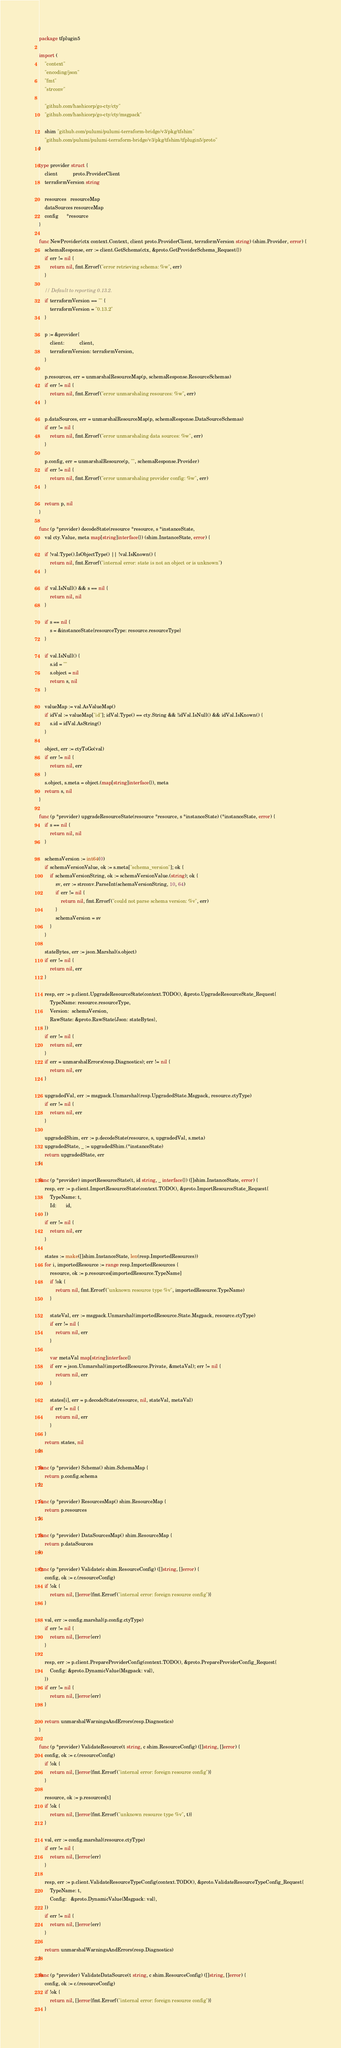<code> <loc_0><loc_0><loc_500><loc_500><_Go_>package tfplugin5

import (
	"context"
	"encoding/json"
	"fmt"
	"strconv"

	"github.com/hashicorp/go-cty/cty"
	"github.com/hashicorp/go-cty/cty/msgpack"

	shim "github.com/pulumi/pulumi-terraform-bridge/v3/pkg/tfshim"
	"github.com/pulumi/pulumi-terraform-bridge/v3/pkg/tfshim/tfplugin5/proto"
)

type provider struct {
	client           proto.ProviderClient
	terraformVersion string

	resources   resourceMap
	dataSources resourceMap
	config      *resource
}

func NewProvider(ctx context.Context, client proto.ProviderClient, terraformVersion string) (shim.Provider, error) {
	schemaResponse, err := client.GetSchema(ctx, &proto.GetProviderSchema_Request{})
	if err != nil {
		return nil, fmt.Errorf("error retrieving schema: %w", err)
	}

	// Default to reporting 0.13.2.
	if terraformVersion == "" {
		terraformVersion = "0.13.2"
	}

	p := &provider{
		client:           client,
		terraformVersion: terraformVersion,
	}

	p.resources, err = unmarshalResourceMap(p, schemaResponse.ResourceSchemas)
	if err != nil {
		return nil, fmt.Errorf("error unmarshaling resources: %w", err)
	}

	p.dataSources, err = unmarshalResourceMap(p, schemaResponse.DataSourceSchemas)
	if err != nil {
		return nil, fmt.Errorf("error unmarshaling data sources: %w", err)
	}

	p.config, err = unmarshalResource(p, "", schemaResponse.Provider)
	if err != nil {
		return nil, fmt.Errorf("error unmarshaling provider config: %w", err)
	}

	return p, nil
}

func (p *provider) decodeState(resource *resource, s *instanceState,
	val cty.Value, meta map[string]interface{}) (shim.InstanceState, error) {

	if !val.Type().IsObjectType() || !val.IsKnown() {
		return nil, fmt.Errorf("internal error: state is not an object or is unknown")
	}

	if val.IsNull() && s == nil {
		return nil, nil
	}

	if s == nil {
		s = &instanceState{resourceType: resource.resourceType}
	}

	if val.IsNull() {
		s.id = ""
		s.object = nil
		return s, nil
	}

	valueMap := val.AsValueMap()
	if idVal := valueMap["id"]; idVal.Type() == cty.String && !idVal.IsNull() && idVal.IsKnown() {
		s.id = idVal.AsString()
	}

	object, err := ctyToGo(val)
	if err != nil {
		return nil, err
	}
	s.object, s.meta = object.(map[string]interface{}), meta
	return s, nil
}

func (p *provider) upgradeResourceState(resource *resource, s *instanceState) (*instanceState, error) {
	if s == nil {
		return nil, nil
	}

	schemaVersion := int64(0)
	if schemaVersionValue, ok := s.meta["schema_version"]; ok {
		if schemaVersionString, ok := schemaVersionValue.(string); ok {
			sv, err := strconv.ParseInt(schemaVersionString, 10, 64)
			if err != nil {
				return nil, fmt.Errorf("could not parse schema version: %v", err)
			}
			schemaVersion = sv
		}
	}

	stateBytes, err := json.Marshal(s.object)
	if err != nil {
		return nil, err
	}

	resp, err := p.client.UpgradeResourceState(context.TODO(), &proto.UpgradeResourceState_Request{
		TypeName: resource.resourceType,
		Version:  schemaVersion,
		RawState: &proto.RawState{Json: stateBytes},
	})
	if err != nil {
		return nil, err
	}
	if err = unmarshalErrors(resp.Diagnostics); err != nil {
		return nil, err
	}

	upgradedVal, err := msgpack.Unmarshal(resp.UpgradedState.Msgpack, resource.ctyType)
	if err != nil {
		return nil, err
	}

	upgradedShim, err := p.decodeState(resource, s, upgradedVal, s.meta)
	upgradedState, _ := upgradedShim.(*instanceState)
	return upgradedState, err
}

func (p *provider) importResourceState(t, id string, _ interface{}) ([]shim.InstanceState, error) {
	resp, err := p.client.ImportResourceState(context.TODO(), &proto.ImportResourceState_Request{
		TypeName: t,
		Id:       id,
	})
	if err != nil {
		return nil, err
	}

	states := make([]shim.InstanceState, len(resp.ImportedResources))
	for i, importedResource := range resp.ImportedResources {
		resource, ok := p.resources[importedResource.TypeName]
		if !ok {
			return nil, fmt.Errorf("unknown resource type %v", importedResource.TypeName)
		}

		stateVal, err := msgpack.Unmarshal(importedResource.State.Msgpack, resource.ctyType)
		if err != nil {
			return nil, err
		}

		var metaVal map[string]interface{}
		if err = json.Unmarshal(importedResource.Private, &metaVal); err != nil {
			return nil, err
		}

		states[i], err = p.decodeState(resource, nil, stateVal, metaVal)
		if err != nil {
			return nil, err
		}
	}
	return states, nil
}

func (p *provider) Schema() shim.SchemaMap {
	return p.config.schema
}

func (p *provider) ResourcesMap() shim.ResourceMap {
	return p.resources
}

func (p *provider) DataSourcesMap() shim.ResourceMap {
	return p.dataSources
}

func (p *provider) Validate(c shim.ResourceConfig) ([]string, []error) {
	config, ok := c.(resourceConfig)
	if !ok {
		return nil, []error{fmt.Errorf("internal error: foreign resource config")}
	}

	val, err := config.marshal(p.config.ctyType)
	if err != nil {
		return nil, []error{err}
	}

	resp, err := p.client.PrepareProviderConfig(context.TODO(), &proto.PrepareProviderConfig_Request{
		Config: &proto.DynamicValue{Msgpack: val},
	})
	if err != nil {
		return nil, []error{err}
	}

	return unmarshalWarningsAndErrors(resp.Diagnostics)
}

func (p *provider) ValidateResource(t string, c shim.ResourceConfig) ([]string, []error) {
	config, ok := c.(resourceConfig)
	if !ok {
		return nil, []error{fmt.Errorf("internal error: foreign resource config")}
	}

	resource, ok := p.resources[t]
	if !ok {
		return nil, []error{fmt.Errorf("unknown resource type %v", t)}
	}

	val, err := config.marshal(resource.ctyType)
	if err != nil {
		return nil, []error{err}
	}

	resp, err := p.client.ValidateResourceTypeConfig(context.TODO(), &proto.ValidateResourceTypeConfig_Request{
		TypeName: t,
		Config:   &proto.DynamicValue{Msgpack: val},
	})
	if err != nil {
		return nil, []error{err}
	}

	return unmarshalWarningsAndErrors(resp.Diagnostics)
}

func (p *provider) ValidateDataSource(t string, c shim.ResourceConfig) ([]string, []error) {
	config, ok := c.(resourceConfig)
	if !ok {
		return nil, []error{fmt.Errorf("internal error: foreign resource config")}
	}
</code> 